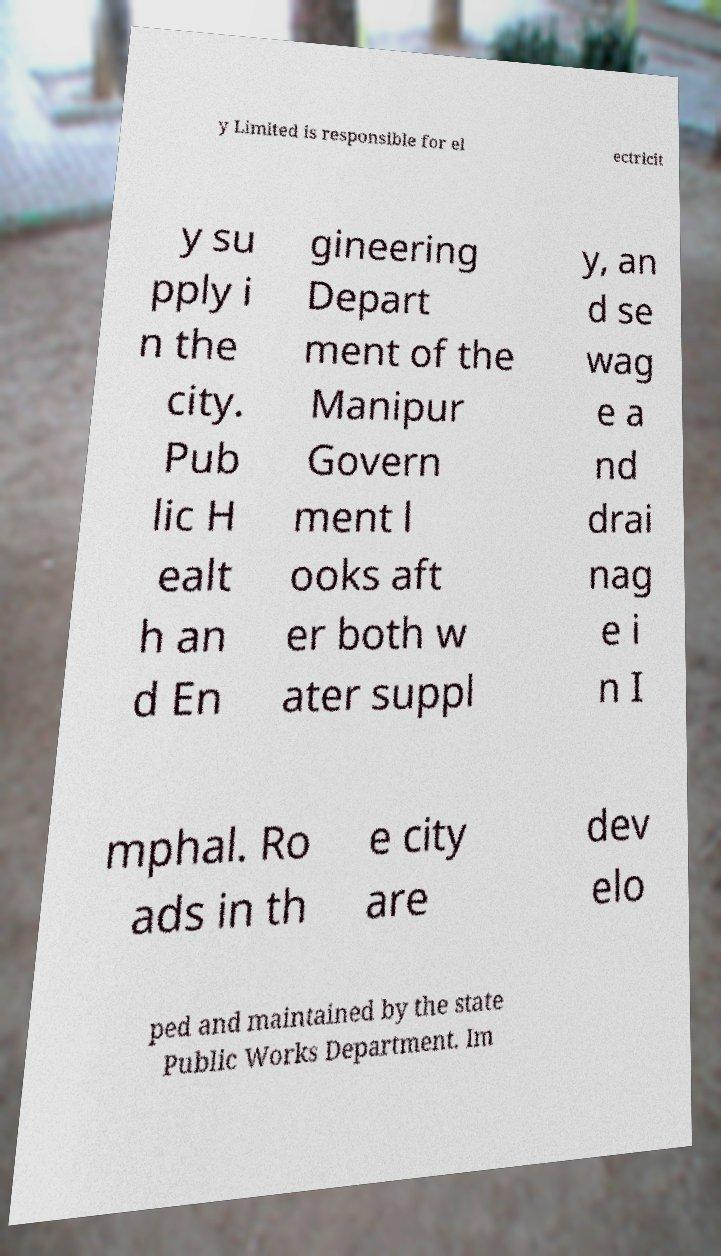Can you read and provide the text displayed in the image?This photo seems to have some interesting text. Can you extract and type it out for me? y Limited is responsible for el ectricit y su pply i n the city. Pub lic H ealt h an d En gineering Depart ment of the Manipur Govern ment l ooks aft er both w ater suppl y, an d se wag e a nd drai nag e i n I mphal. Ro ads in th e city are dev elo ped and maintained by the state Public Works Department. Im 